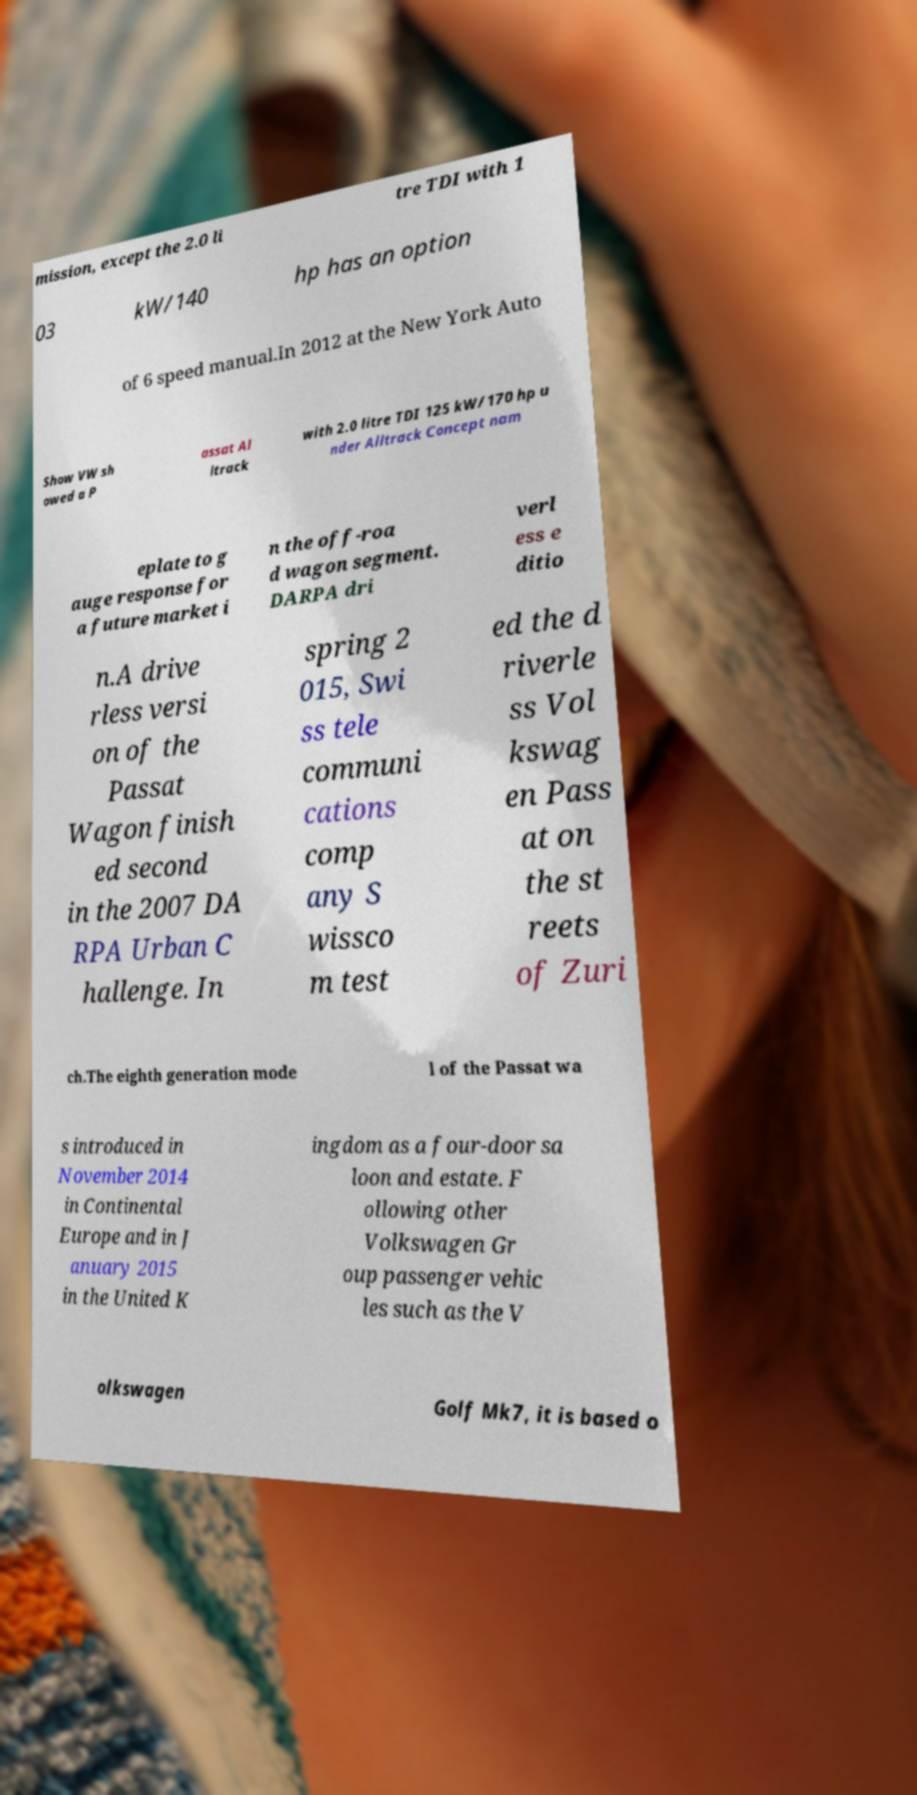Can you read and provide the text displayed in the image?This photo seems to have some interesting text. Can you extract and type it out for me? mission, except the 2.0 li tre TDI with 1 03 kW/140 hp has an option of 6 speed manual.In 2012 at the New York Auto Show VW sh owed a P assat Al ltrack with 2.0 litre TDI 125 kW/170 hp u nder Alltrack Concept nam eplate to g auge response for a future market i n the off-roa d wagon segment. DARPA dri verl ess e ditio n.A drive rless versi on of the Passat Wagon finish ed second in the 2007 DA RPA Urban C hallenge. In spring 2 015, Swi ss tele communi cations comp any S wissco m test ed the d riverle ss Vol kswag en Pass at on the st reets of Zuri ch.The eighth generation mode l of the Passat wa s introduced in November 2014 in Continental Europe and in J anuary 2015 in the United K ingdom as a four-door sa loon and estate. F ollowing other Volkswagen Gr oup passenger vehic les such as the V olkswagen Golf Mk7, it is based o 